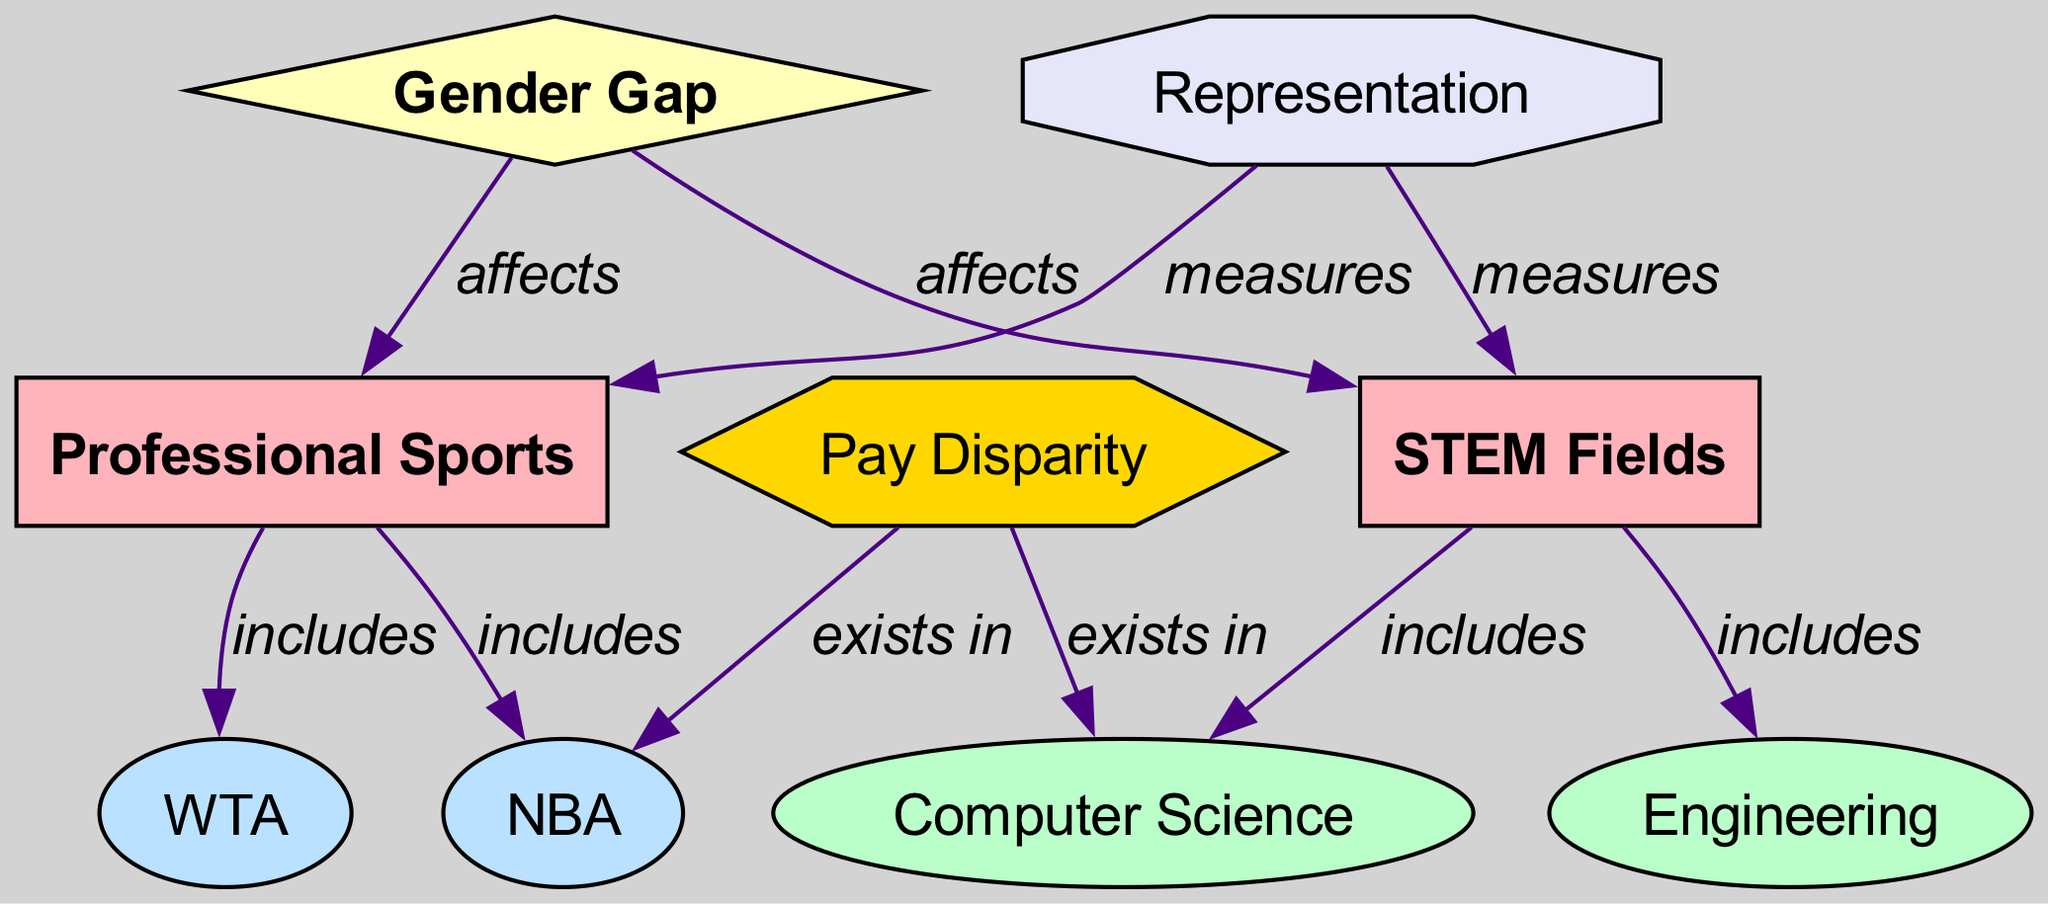What are the two main categories depicted in the diagram? The diagram contains two main categories, which are indicated as nodes with the label "category." These are "STEM Fields" and "Professional Sports."
Answer: STEM Fields, Professional Sports Which STEM fields are included in the diagram? The diagram illustrates the relation between the category of "STEM Fields" and specific STEM fields such as "Computer Science" and "Engineering" through the "includes" edges.
Answer: Computer Science, Engineering What sports leagues are represented in the diagram? The sports leagues represented are derived from the category of "Professional Sports." The leagues shown are "NBA" and "WTA," which are connected to the category node.
Answer: NBA, WTA How many edges are there in total in this diagram? To determine the number of edges, we count the connections (relationships) between nodes. In this case, there are a total of 10 edges as listed in the data section.
Answer: 10 Which concept affects both STEM fields and professional sports? The concept named "Gender Gap" is shown in the diagram with directed edges affecting both "STEM Fields" and "Professional Sports," indicating a relationship consistent across both categories.
Answer: Gender Gap Does Pay Disparity exist in both Computer Science and NBA? The diagram specifies that "Pay Disparity" exists in both "Computer Science" and "NBA," which is evident from its connections to both nodes.
Answer: Yes How does representation serve as a metric in this diagram? The diagram shows that "Representation" is a metric that measures both "STEM Fields" and "Professional Sports," indicating its role in assessing gender representation across both domains.
Answer: Measures What is the relationship between Pay Disparity and the concept of Gender Gap? Pay Disparity is indicated in the diagram to exist in both "Computer Science" and "NBA," while the Gender Gap is shown to affect both "STEM Fields" and "Professional Sports." This suggests a connection as Pay Disparity may stem from the Gender Gap.
Answer: Exists in Which concept is illustrated to measure both categories? The concept of "Representation" is illustrated to measure both "STEM Fields" and "Professional Sports," as shown by the edges connected to both categories indicating that they are assessed based on representation metrics.
Answer: Representation 